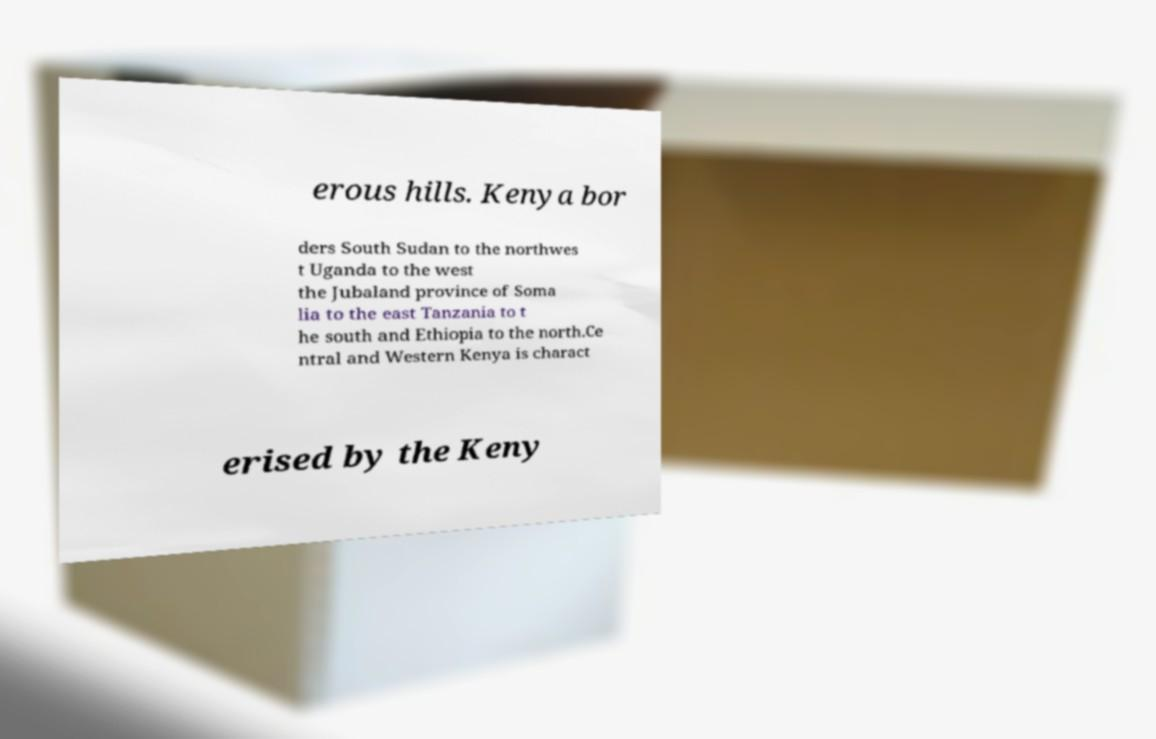For documentation purposes, I need the text within this image transcribed. Could you provide that? erous hills. Kenya bor ders South Sudan to the northwes t Uganda to the west the Jubaland province of Soma lia to the east Tanzania to t he south and Ethiopia to the north.Ce ntral and Western Kenya is charact erised by the Keny 